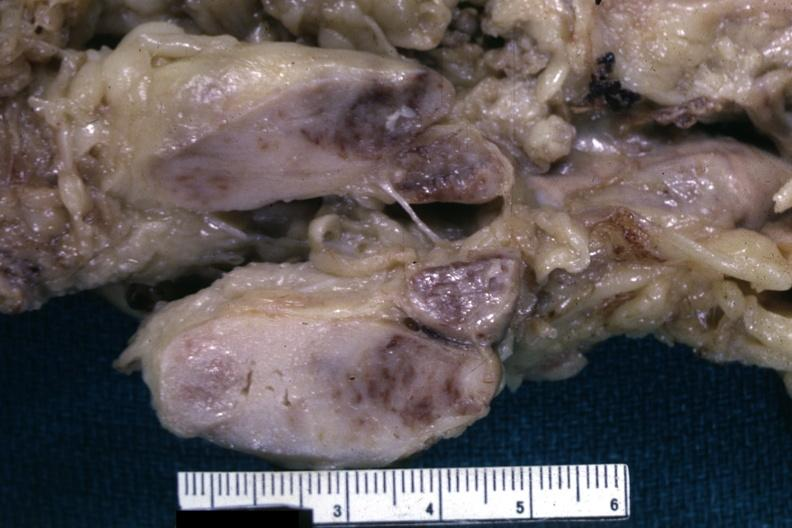s lymph node present?
Answer the question using a single word or phrase. Yes 